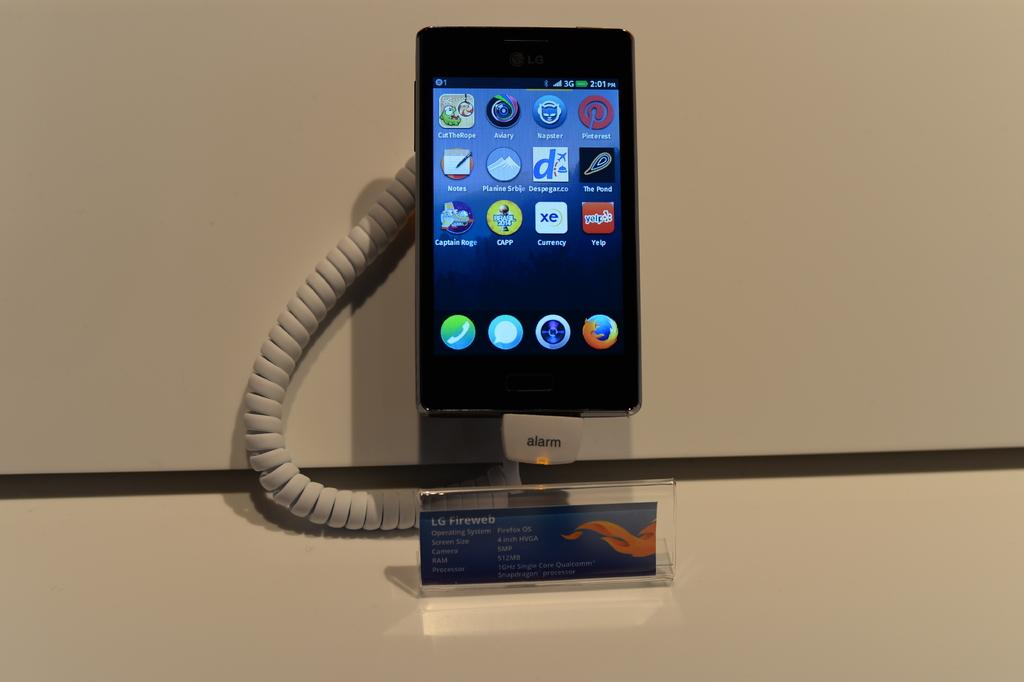<image>
Offer a succinct explanation of the picture presented. A display of an LG Fireweb device with notation that there is an alarm. 